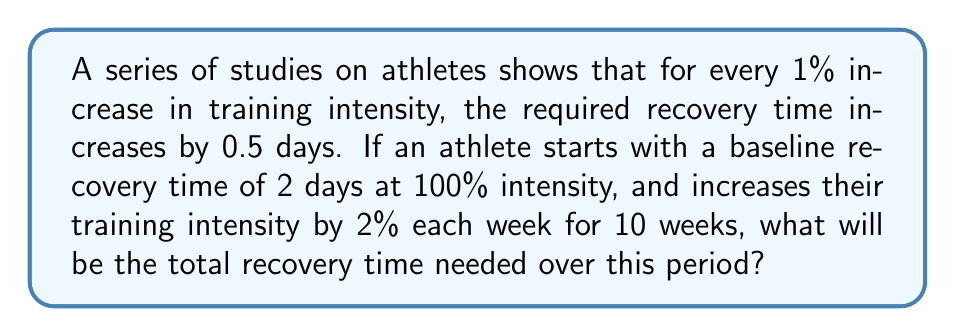Show me your answer to this math problem. Let's approach this step-by-step:

1) First, let's establish the arithmetic sequence for the training intensity:
   $a_1 = 100\%$, $d = 2\%$, $n = 10$
   The sequence is: $100\%, 102\%, 104\%, ..., 118\%$

2) Now, let's create a sequence for the recovery time:
   - Initial recovery time: 2 days
   - Each 2% increase adds 1 day (0.5 days per 1%)

   So the sequence is: $2, 3, 4, ..., 11$ days

3) We need to find the sum of this arithmetic sequence. The formula is:
   
   $$S_n = \frac{n}{2}(a_1 + a_n)$$

   Where $a_1$ is the first term, $a_n$ is the last term, and $n$ is the number of terms.

4) In our case:
   $a_1 = 2$, $a_n = 11$, $n = 10$

5) Plugging into the formula:

   $$S_{10} = \frac{10}{2}(2 + 11) = 5(13) = 65$$

Therefore, the total recovery time needed over the 10-week period is 65 days.
Answer: 65 days 